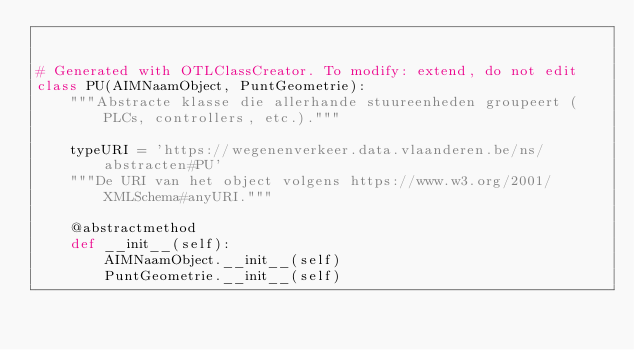<code> <loc_0><loc_0><loc_500><loc_500><_Python_>

# Generated with OTLClassCreator. To modify: extend, do not edit
class PU(AIMNaamObject, PuntGeometrie):
    """Abstracte klasse die allerhande stuureenheden groupeert (PLCs, controllers, etc.)."""

    typeURI = 'https://wegenenverkeer.data.vlaanderen.be/ns/abstracten#PU'
    """De URI van het object volgens https://www.w3.org/2001/XMLSchema#anyURI."""

    @abstractmethod
    def __init__(self):
        AIMNaamObject.__init__(self)
        PuntGeometrie.__init__(self)
</code> 